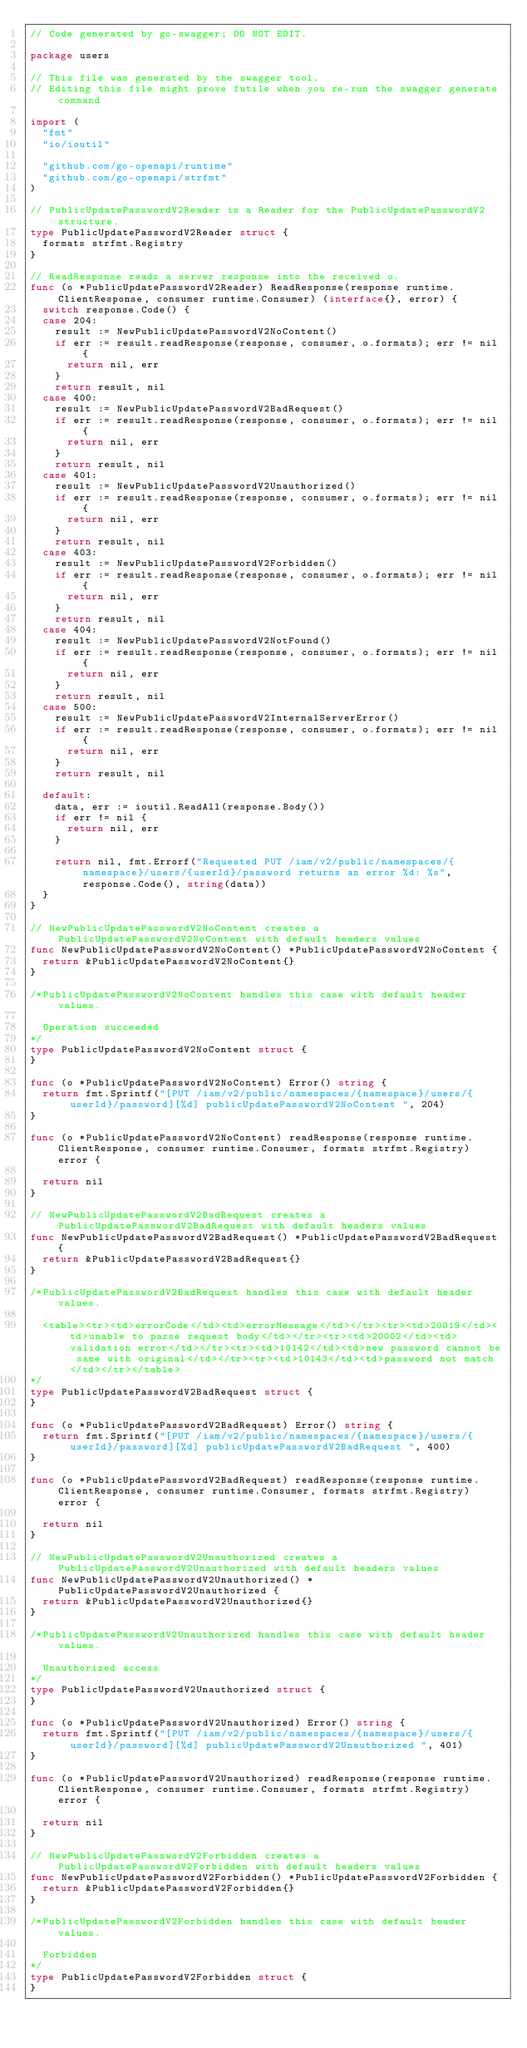Convert code to text. <code><loc_0><loc_0><loc_500><loc_500><_Go_>// Code generated by go-swagger; DO NOT EDIT.

package users

// This file was generated by the swagger tool.
// Editing this file might prove futile when you re-run the swagger generate command

import (
	"fmt"
	"io/ioutil"

	"github.com/go-openapi/runtime"
	"github.com/go-openapi/strfmt"
)

// PublicUpdatePasswordV2Reader is a Reader for the PublicUpdatePasswordV2 structure.
type PublicUpdatePasswordV2Reader struct {
	formats strfmt.Registry
}

// ReadResponse reads a server response into the received o.
func (o *PublicUpdatePasswordV2Reader) ReadResponse(response runtime.ClientResponse, consumer runtime.Consumer) (interface{}, error) {
	switch response.Code() {
	case 204:
		result := NewPublicUpdatePasswordV2NoContent()
		if err := result.readResponse(response, consumer, o.formats); err != nil {
			return nil, err
		}
		return result, nil
	case 400:
		result := NewPublicUpdatePasswordV2BadRequest()
		if err := result.readResponse(response, consumer, o.formats); err != nil {
			return nil, err
		}
		return result, nil
	case 401:
		result := NewPublicUpdatePasswordV2Unauthorized()
		if err := result.readResponse(response, consumer, o.formats); err != nil {
			return nil, err
		}
		return result, nil
	case 403:
		result := NewPublicUpdatePasswordV2Forbidden()
		if err := result.readResponse(response, consumer, o.formats); err != nil {
			return nil, err
		}
		return result, nil
	case 404:
		result := NewPublicUpdatePasswordV2NotFound()
		if err := result.readResponse(response, consumer, o.formats); err != nil {
			return nil, err
		}
		return result, nil
	case 500:
		result := NewPublicUpdatePasswordV2InternalServerError()
		if err := result.readResponse(response, consumer, o.formats); err != nil {
			return nil, err
		}
		return result, nil

	default:
		data, err := ioutil.ReadAll(response.Body())
		if err != nil {
			return nil, err
		}

		return nil, fmt.Errorf("Requested PUT /iam/v2/public/namespaces/{namespace}/users/{userId}/password returns an error %d: %s", response.Code(), string(data))
	}
}

// NewPublicUpdatePasswordV2NoContent creates a PublicUpdatePasswordV2NoContent with default headers values
func NewPublicUpdatePasswordV2NoContent() *PublicUpdatePasswordV2NoContent {
	return &PublicUpdatePasswordV2NoContent{}
}

/*PublicUpdatePasswordV2NoContent handles this case with default header values.

  Operation succeeded
*/
type PublicUpdatePasswordV2NoContent struct {
}

func (o *PublicUpdatePasswordV2NoContent) Error() string {
	return fmt.Sprintf("[PUT /iam/v2/public/namespaces/{namespace}/users/{userId}/password][%d] publicUpdatePasswordV2NoContent ", 204)
}

func (o *PublicUpdatePasswordV2NoContent) readResponse(response runtime.ClientResponse, consumer runtime.Consumer, formats strfmt.Registry) error {

	return nil
}

// NewPublicUpdatePasswordV2BadRequest creates a PublicUpdatePasswordV2BadRequest with default headers values
func NewPublicUpdatePasswordV2BadRequest() *PublicUpdatePasswordV2BadRequest {
	return &PublicUpdatePasswordV2BadRequest{}
}

/*PublicUpdatePasswordV2BadRequest handles this case with default header values.

  <table><tr><td>errorCode</td><td>errorMessage</td></tr><tr><td>20019</td><td>unable to parse request body</td></tr><tr><td>20002</td><td>validation error</td></tr><tr><td>10142</td><td>new password cannot be same with original</td></tr><tr><td>10143</td><td>password not match</td></tr></table>
*/
type PublicUpdatePasswordV2BadRequest struct {
}

func (o *PublicUpdatePasswordV2BadRequest) Error() string {
	return fmt.Sprintf("[PUT /iam/v2/public/namespaces/{namespace}/users/{userId}/password][%d] publicUpdatePasswordV2BadRequest ", 400)
}

func (o *PublicUpdatePasswordV2BadRequest) readResponse(response runtime.ClientResponse, consumer runtime.Consumer, formats strfmt.Registry) error {

	return nil
}

// NewPublicUpdatePasswordV2Unauthorized creates a PublicUpdatePasswordV2Unauthorized with default headers values
func NewPublicUpdatePasswordV2Unauthorized() *PublicUpdatePasswordV2Unauthorized {
	return &PublicUpdatePasswordV2Unauthorized{}
}

/*PublicUpdatePasswordV2Unauthorized handles this case with default header values.

  Unauthorized access
*/
type PublicUpdatePasswordV2Unauthorized struct {
}

func (o *PublicUpdatePasswordV2Unauthorized) Error() string {
	return fmt.Sprintf("[PUT /iam/v2/public/namespaces/{namespace}/users/{userId}/password][%d] publicUpdatePasswordV2Unauthorized ", 401)
}

func (o *PublicUpdatePasswordV2Unauthorized) readResponse(response runtime.ClientResponse, consumer runtime.Consumer, formats strfmt.Registry) error {

	return nil
}

// NewPublicUpdatePasswordV2Forbidden creates a PublicUpdatePasswordV2Forbidden with default headers values
func NewPublicUpdatePasswordV2Forbidden() *PublicUpdatePasswordV2Forbidden {
	return &PublicUpdatePasswordV2Forbidden{}
}

/*PublicUpdatePasswordV2Forbidden handles this case with default header values.

  Forbidden
*/
type PublicUpdatePasswordV2Forbidden struct {
}
</code> 